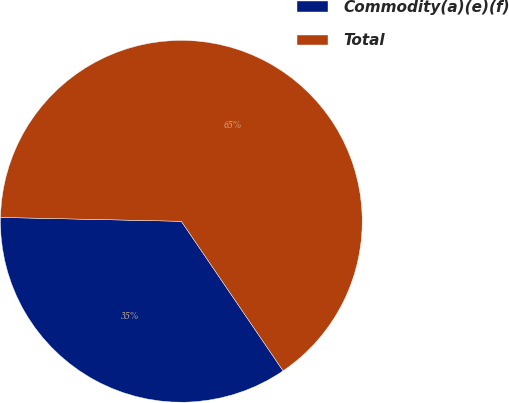Convert chart to OTSL. <chart><loc_0><loc_0><loc_500><loc_500><pie_chart><fcel>Commodity(a)(e)(f)<fcel>Total<nl><fcel>34.85%<fcel>65.15%<nl></chart> 